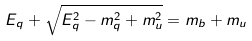Convert formula to latex. <formula><loc_0><loc_0><loc_500><loc_500>E _ { q } + \sqrt { E _ { q } ^ { 2 } - m _ { q } ^ { 2 } + m _ { u } ^ { 2 } } = m _ { b } + m _ { u }</formula> 